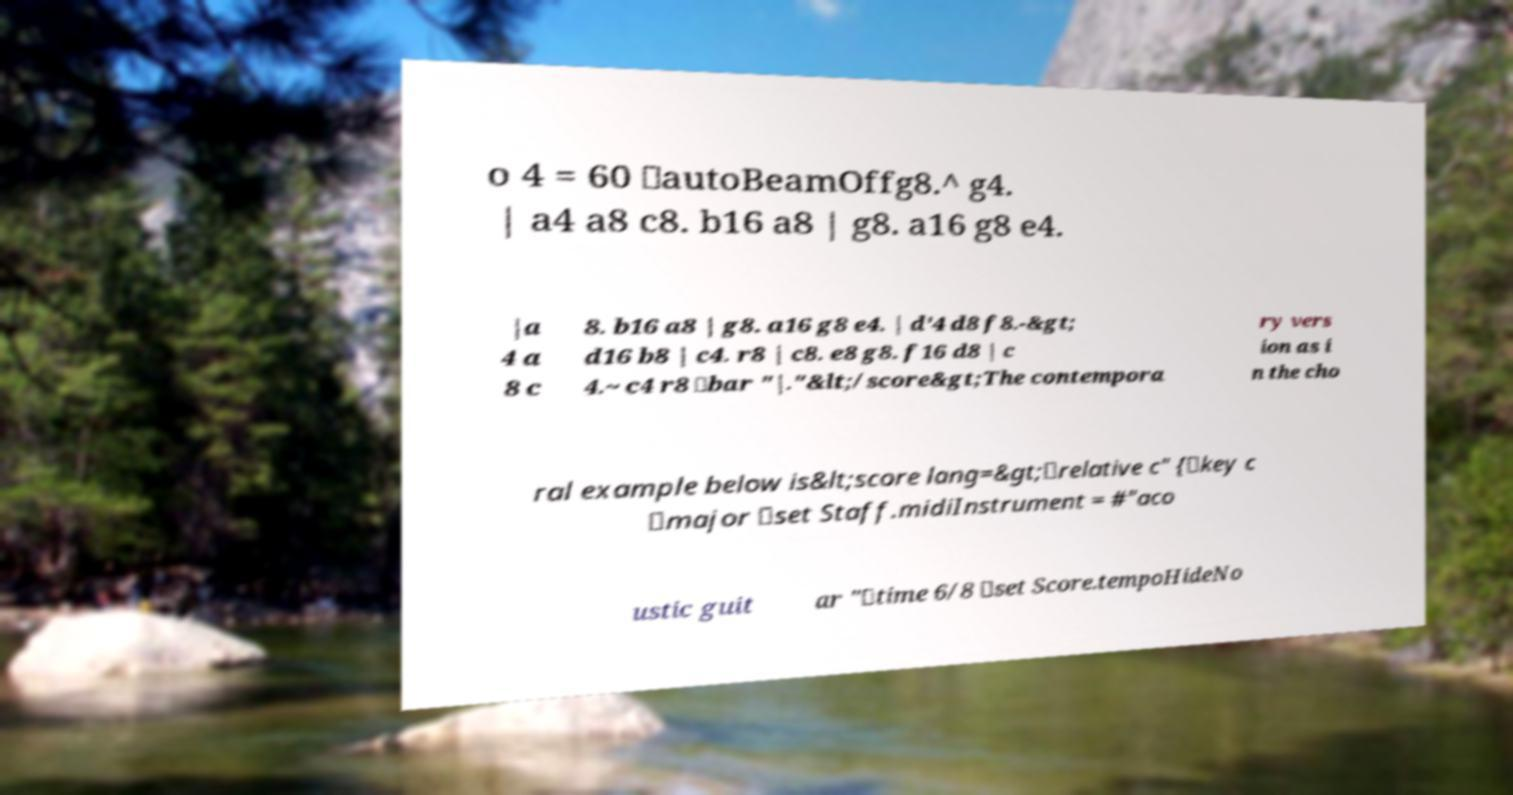What messages or text are displayed in this image? I need them in a readable, typed format. o 4 = 60 \autoBeamOffg8.^ g4. | a4 a8 c8. b16 a8 | g8. a16 g8 e4. |a 4 a 8 c 8. b16 a8 | g8. a16 g8 e4. | d'4 d8 f8.-&gt; d16 b8 | c4. r8 | c8. e8 g8. f16 d8 | c 4.~ c4 r8 \bar "|."&lt;/score&gt;The contempora ry vers ion as i n the cho ral example below is&lt;score lang=&gt;\relative c" {\key c \major \set Staff.midiInstrument = #"aco ustic guit ar "\time 6/8 \set Score.tempoHideNo 